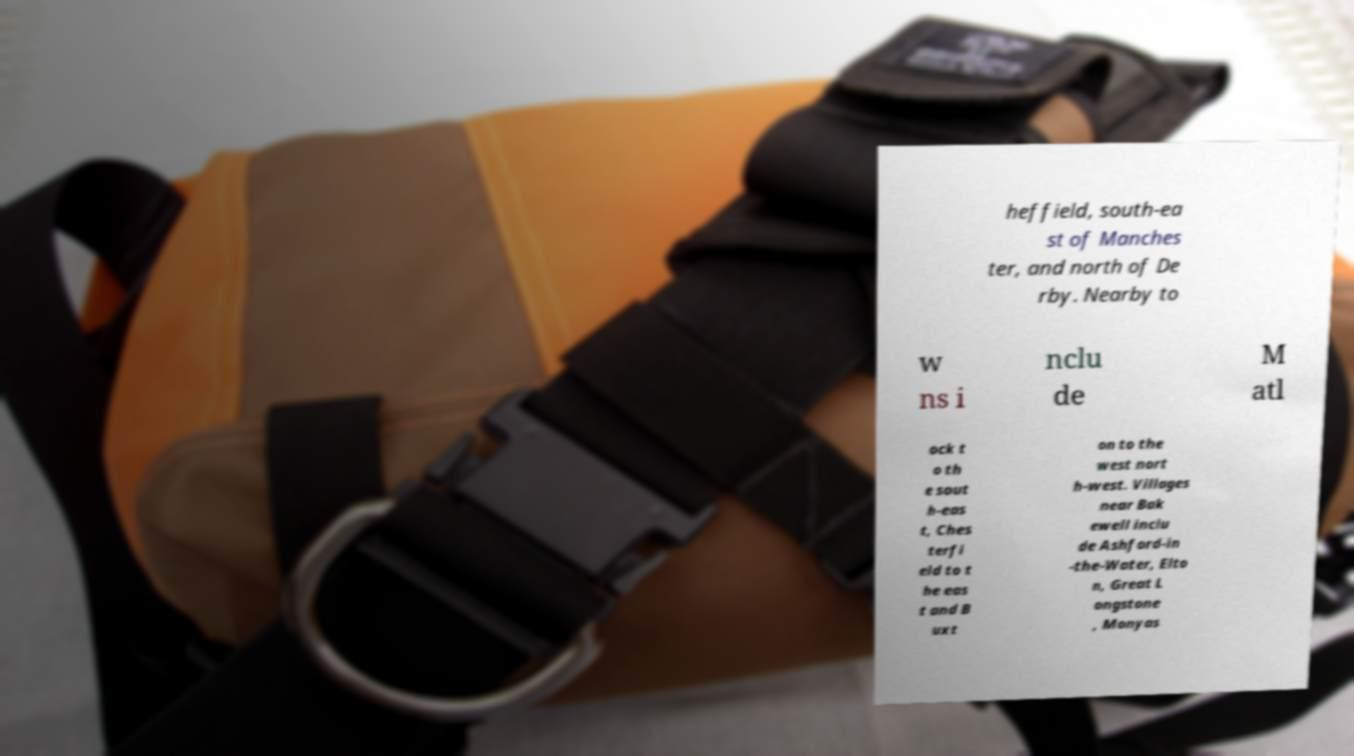Could you extract and type out the text from this image? heffield, south-ea st of Manches ter, and north of De rby. Nearby to w ns i nclu de M atl ock t o th e sout h-eas t, Ches terfi eld to t he eas t and B uxt on to the west nort h-west. Villages near Bak ewell inclu de Ashford-in -the-Water, Elto n, Great L ongstone , Monyas 